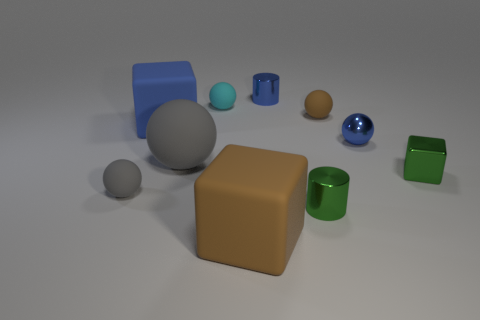What is the shape of the brown object that is the same size as the green metallic cube?
Your answer should be compact. Sphere. Does the cyan thing have the same material as the blue cylinder?
Provide a succinct answer. No. There is a tiny shiny thing that is the same color as the metallic block; what is its shape?
Give a very brief answer. Cylinder. There is a rubber block that is behind the big gray thing; is its color the same as the big sphere?
Ensure brevity in your answer.  No. There is a gray matte object behind the thing that is to the left of the big blue rubber object; what shape is it?
Make the answer very short. Sphere. The small brown object that is the same material as the large brown block is what shape?
Ensure brevity in your answer.  Sphere. There is a tiny object that is the same shape as the big brown thing; what material is it?
Give a very brief answer. Metal. There is a tiny object to the left of the tiny cyan sphere; is its color the same as the tiny metal object that is behind the cyan matte object?
Keep it short and to the point. No. There is a matte block that is behind the small green metal object that is behind the gray thing that is in front of the green cube; how big is it?
Offer a terse response. Large. What is the shape of the matte thing that is on the right side of the big blue matte cube and in front of the small metal block?
Your answer should be very brief. Cube. 